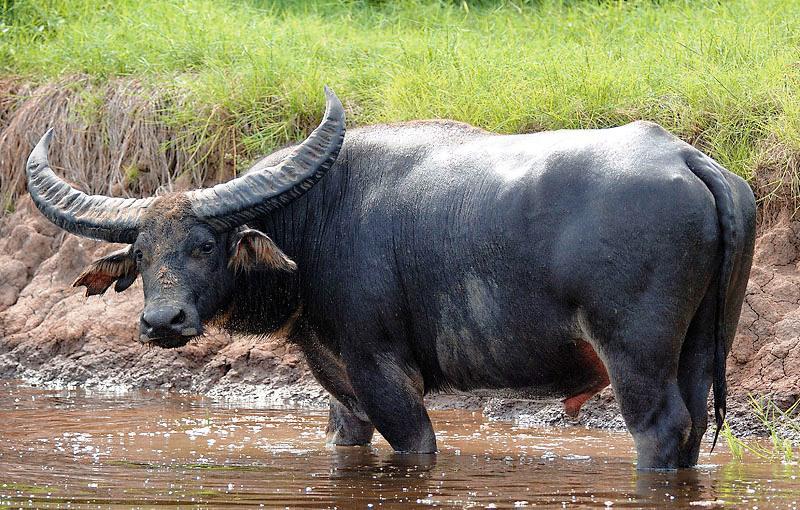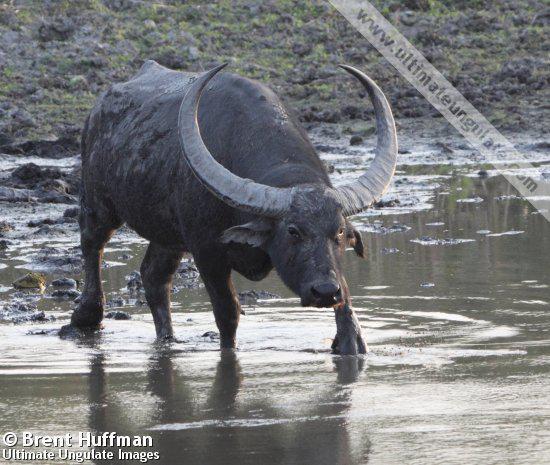The first image is the image on the left, the second image is the image on the right. Given the left and right images, does the statement "At least one image has more than one animal." hold true? Answer yes or no. No. 